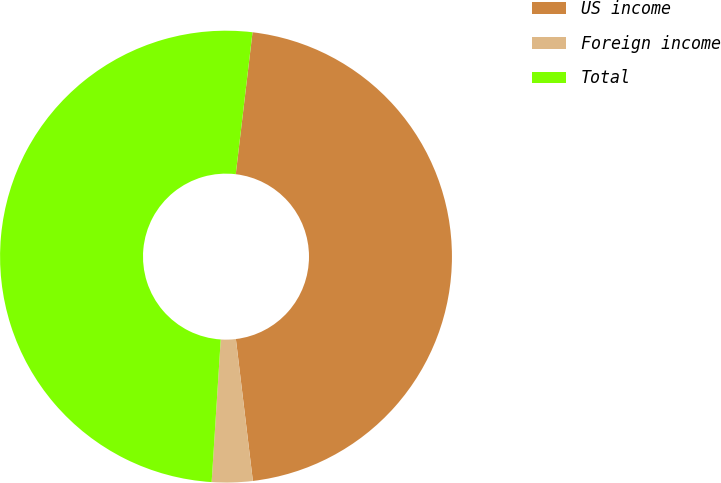<chart> <loc_0><loc_0><loc_500><loc_500><pie_chart><fcel>US income<fcel>Foreign income<fcel>Total<nl><fcel>46.23%<fcel>2.91%<fcel>50.86%<nl></chart> 